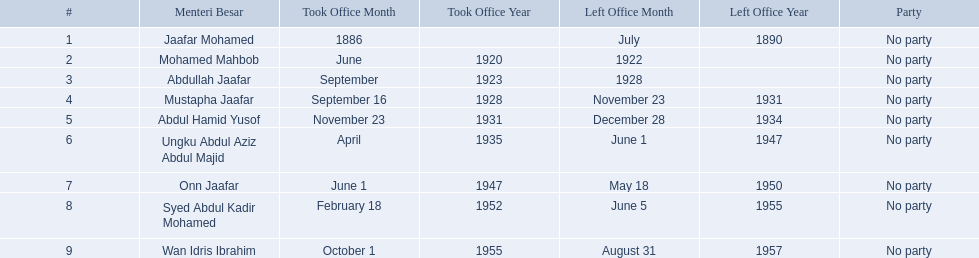Who are all of the menteri besars? Jaafar Mohamed, Mohamed Mahbob, Abdullah Jaafar, Mustapha Jaafar, Abdul Hamid Yusof, Ungku Abdul Aziz Abdul Majid, Onn Jaafar, Syed Abdul Kadir Mohamed, Wan Idris Ibrahim. When did each take office? 1886, June 1920, September 1923, September 16, 1928, November 23, 1931, April 1935, June 1, 1947, February 18, 1952, October 1, 1955. When did they leave? July 1890, 1922, 1928, November 23, 1931, December 28, 1934, June 1, 1947, May 18, 1950, June 5, 1955, August 31, 1957. And which spent the most time in office? Ungku Abdul Aziz Abdul Majid. 